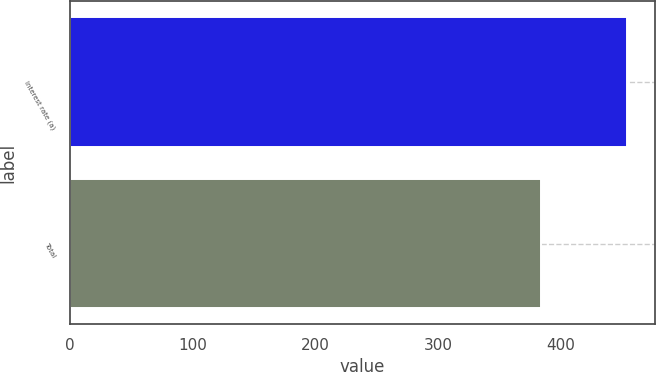<chart> <loc_0><loc_0><loc_500><loc_500><bar_chart><fcel>Interest rate (a)<fcel>Total<nl><fcel>454<fcel>384<nl></chart> 